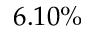Convert formula to latex. <formula><loc_0><loc_0><loc_500><loc_500>6 . 1 0 \%</formula> 